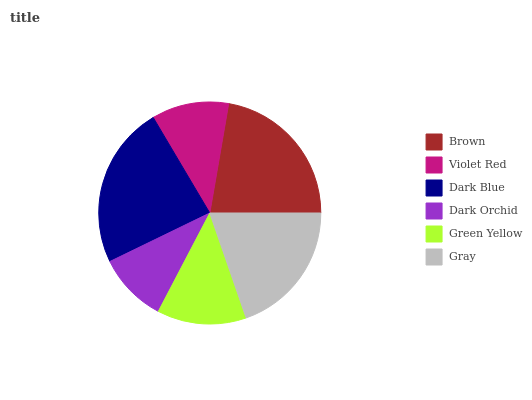Is Dark Orchid the minimum?
Answer yes or no. Yes. Is Dark Blue the maximum?
Answer yes or no. Yes. Is Violet Red the minimum?
Answer yes or no. No. Is Violet Red the maximum?
Answer yes or no. No. Is Brown greater than Violet Red?
Answer yes or no. Yes. Is Violet Red less than Brown?
Answer yes or no. Yes. Is Violet Red greater than Brown?
Answer yes or no. No. Is Brown less than Violet Red?
Answer yes or no. No. Is Gray the high median?
Answer yes or no. Yes. Is Green Yellow the low median?
Answer yes or no. Yes. Is Green Yellow the high median?
Answer yes or no. No. Is Dark Blue the low median?
Answer yes or no. No. 